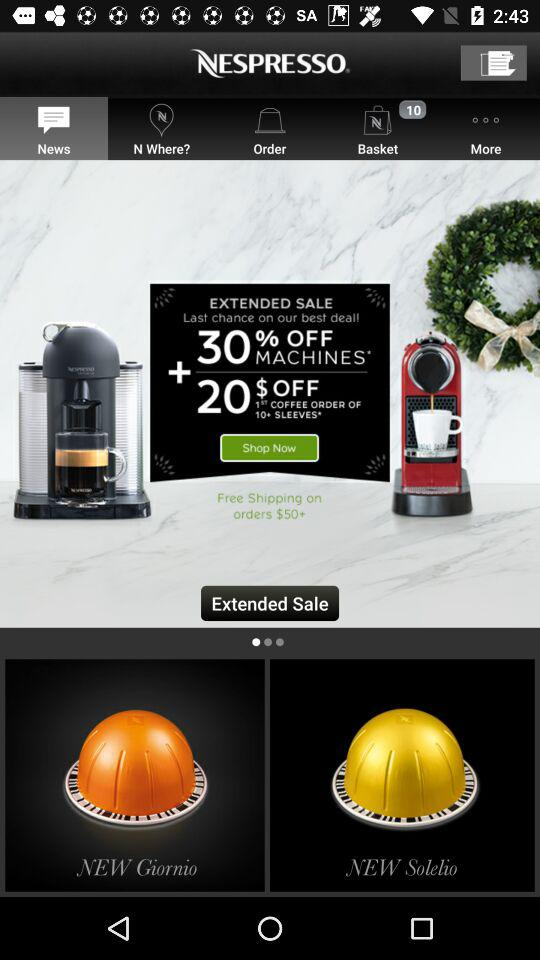How many orders are in the "Basket"? There are 10 orders. 